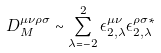Convert formula to latex. <formula><loc_0><loc_0><loc_500><loc_500>D _ { M } ^ { \mu \nu \rho \sigma } \sim \sum _ { \lambda = - 2 } ^ { 2 } \epsilon ^ { \mu \nu } _ { 2 , \lambda } \epsilon ^ { \rho \sigma * } _ { 2 , \lambda }</formula> 